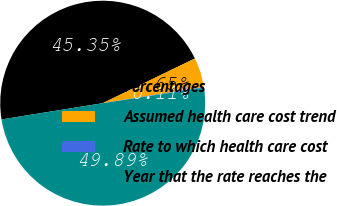<chart> <loc_0><loc_0><loc_500><loc_500><pie_chart><fcel>Percentages<fcel>Assumed health care cost trend<fcel>Rate to which health care cost<fcel>Year that the rate reaches the<nl><fcel>45.35%<fcel>4.65%<fcel>0.11%<fcel>49.89%<nl></chart> 